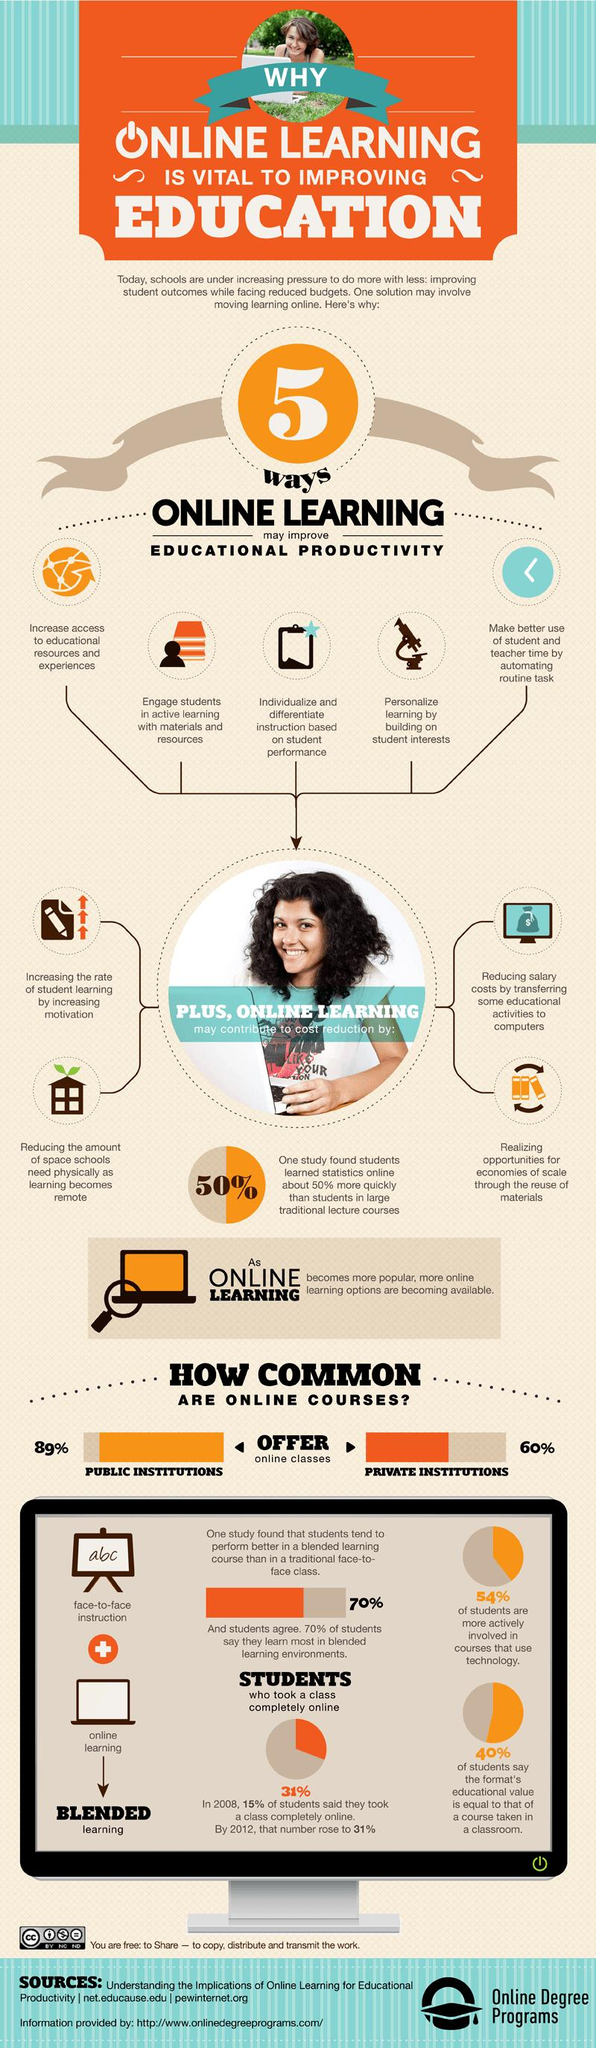List a handful of essential elements in this visual. Students learned statistics 50% more quickly online than through traditional lecture courses. The writing board contains the printed text "abc..". Blended learning is a unique combination of face-to-face instruction and online learning that is designed to maximize the benefits of both approaches and provide a more engaging and effective learning experience for students. During the period from 2008 to 2012, there was a significant increase in the percentage of online students. Specifically, the percentage of online students increased by 16%. Four types of cost reductions have been highlighted. 